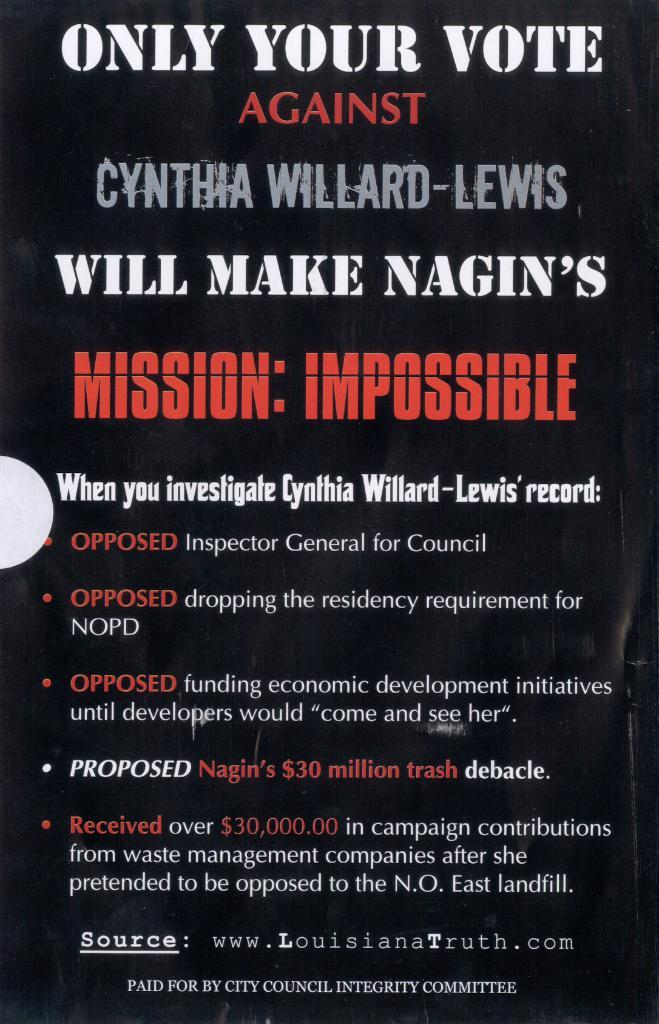<image>
Share a concise interpretation of the image provided. A poster wants you to vote against Cynthia Willard-Lewis. 